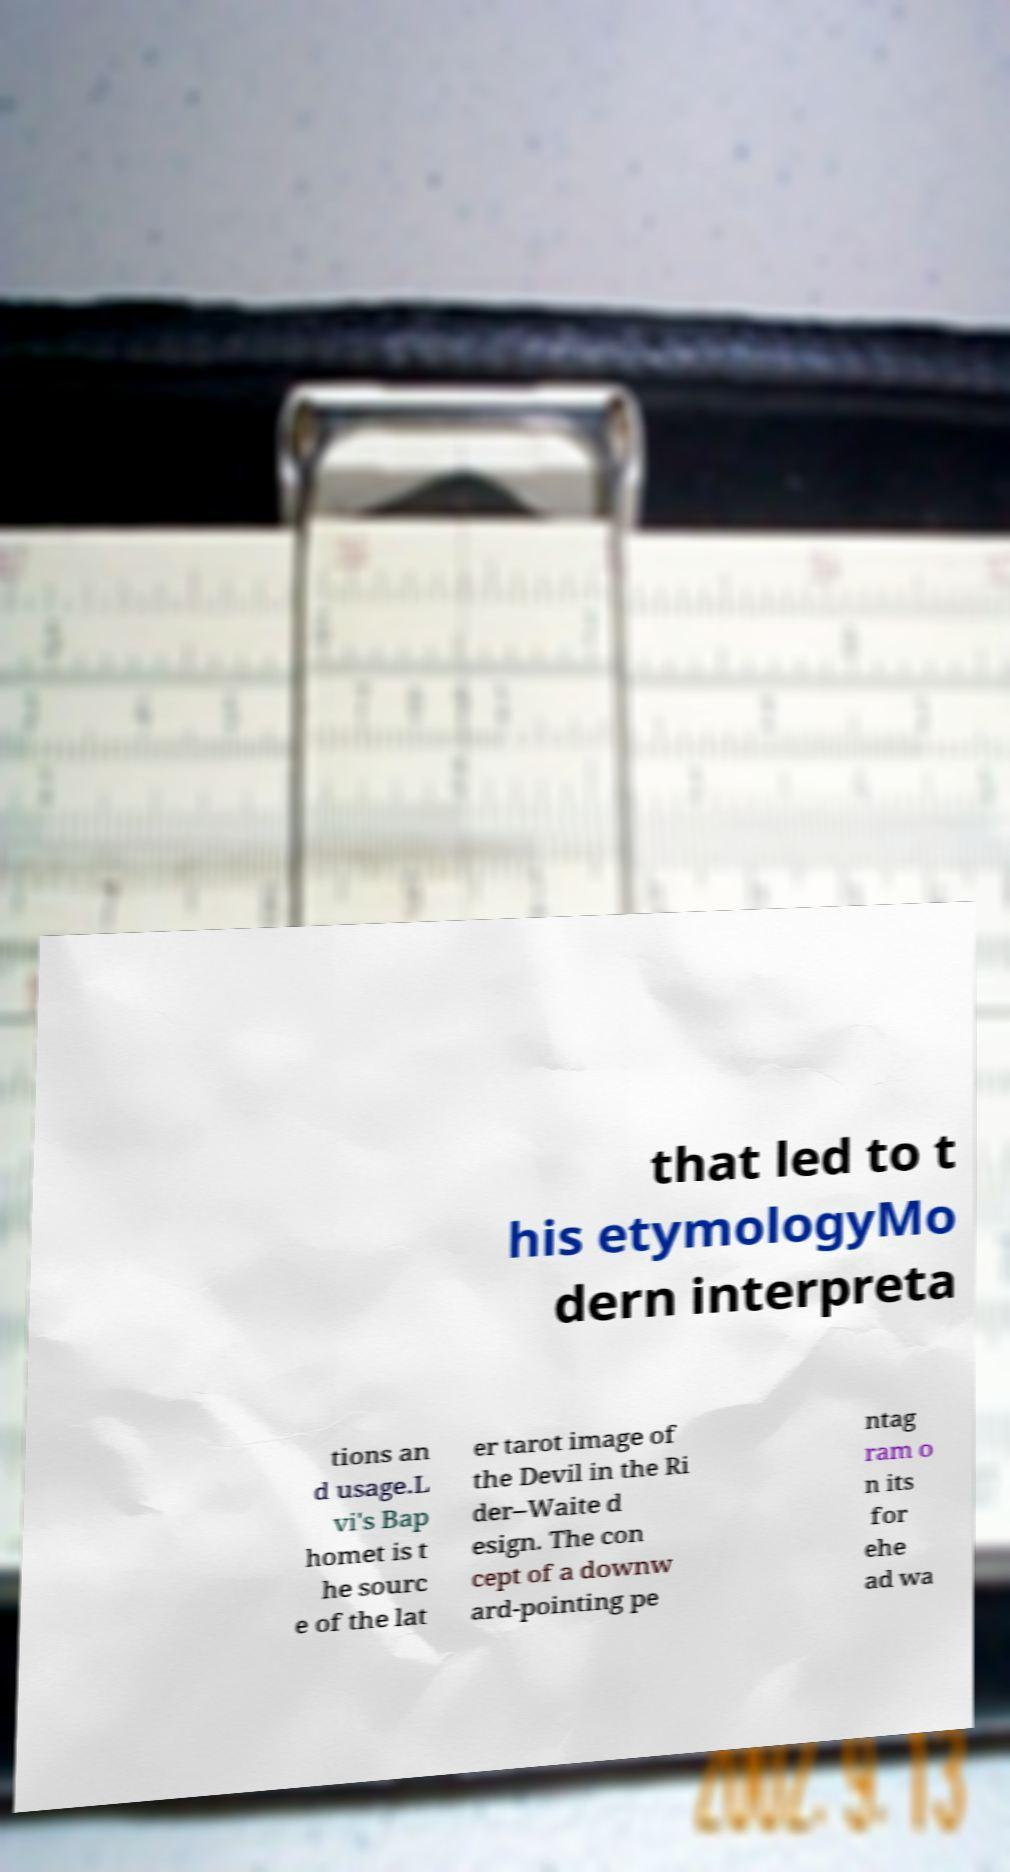Can you read and provide the text displayed in the image?This photo seems to have some interesting text. Can you extract and type it out for me? that led to t his etymologyMo dern interpreta tions an d usage.L vi's Bap homet is t he sourc e of the lat er tarot image of the Devil in the Ri der–Waite d esign. The con cept of a downw ard-pointing pe ntag ram o n its for ehe ad wa 